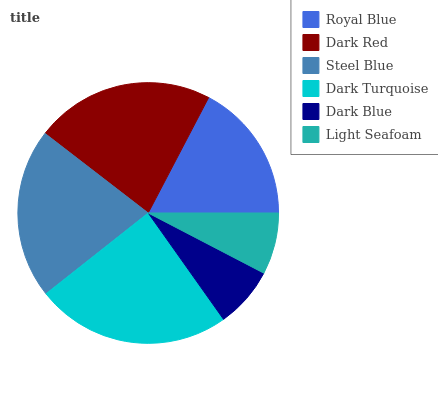Is Dark Blue the minimum?
Answer yes or no. Yes. Is Dark Turquoise the maximum?
Answer yes or no. Yes. Is Dark Red the minimum?
Answer yes or no. No. Is Dark Red the maximum?
Answer yes or no. No. Is Dark Red greater than Royal Blue?
Answer yes or no. Yes. Is Royal Blue less than Dark Red?
Answer yes or no. Yes. Is Royal Blue greater than Dark Red?
Answer yes or no. No. Is Dark Red less than Royal Blue?
Answer yes or no. No. Is Steel Blue the high median?
Answer yes or no. Yes. Is Royal Blue the low median?
Answer yes or no. Yes. Is Light Seafoam the high median?
Answer yes or no. No. Is Steel Blue the low median?
Answer yes or no. No. 